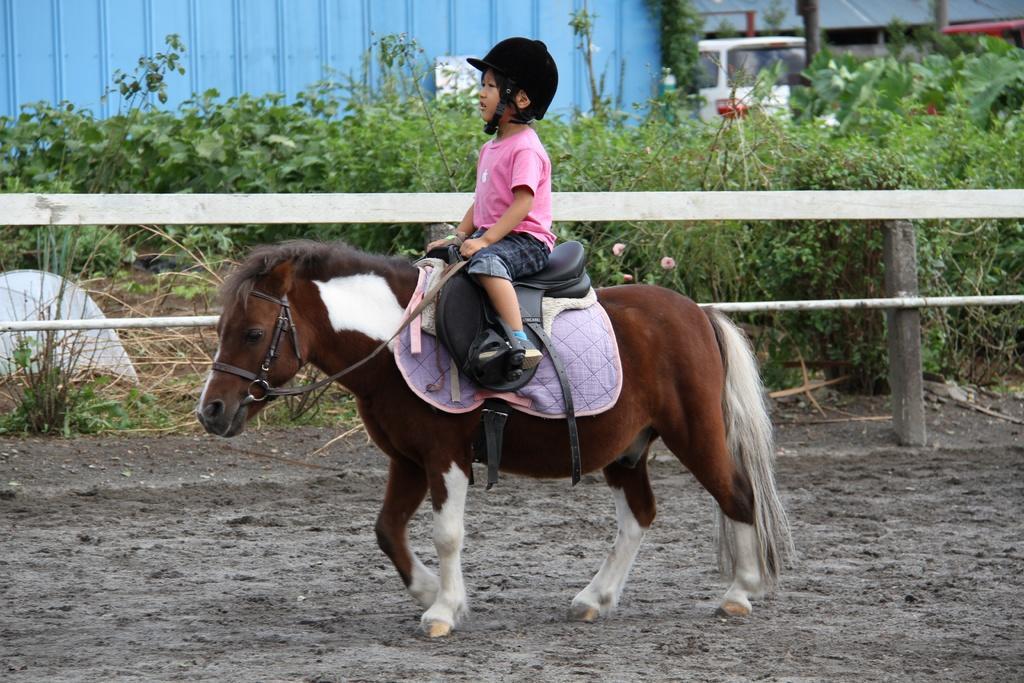How would you summarize this image in a sentence or two? In this image I can see the child sitting on the horse. The child is wearing the pink and blue color dress and also helmet. The horse is in brown and white color. It is standing on the ground. To the side I can see thee railing and the pink color flower to the plants. In the background I can see the shed and the vehicle. 